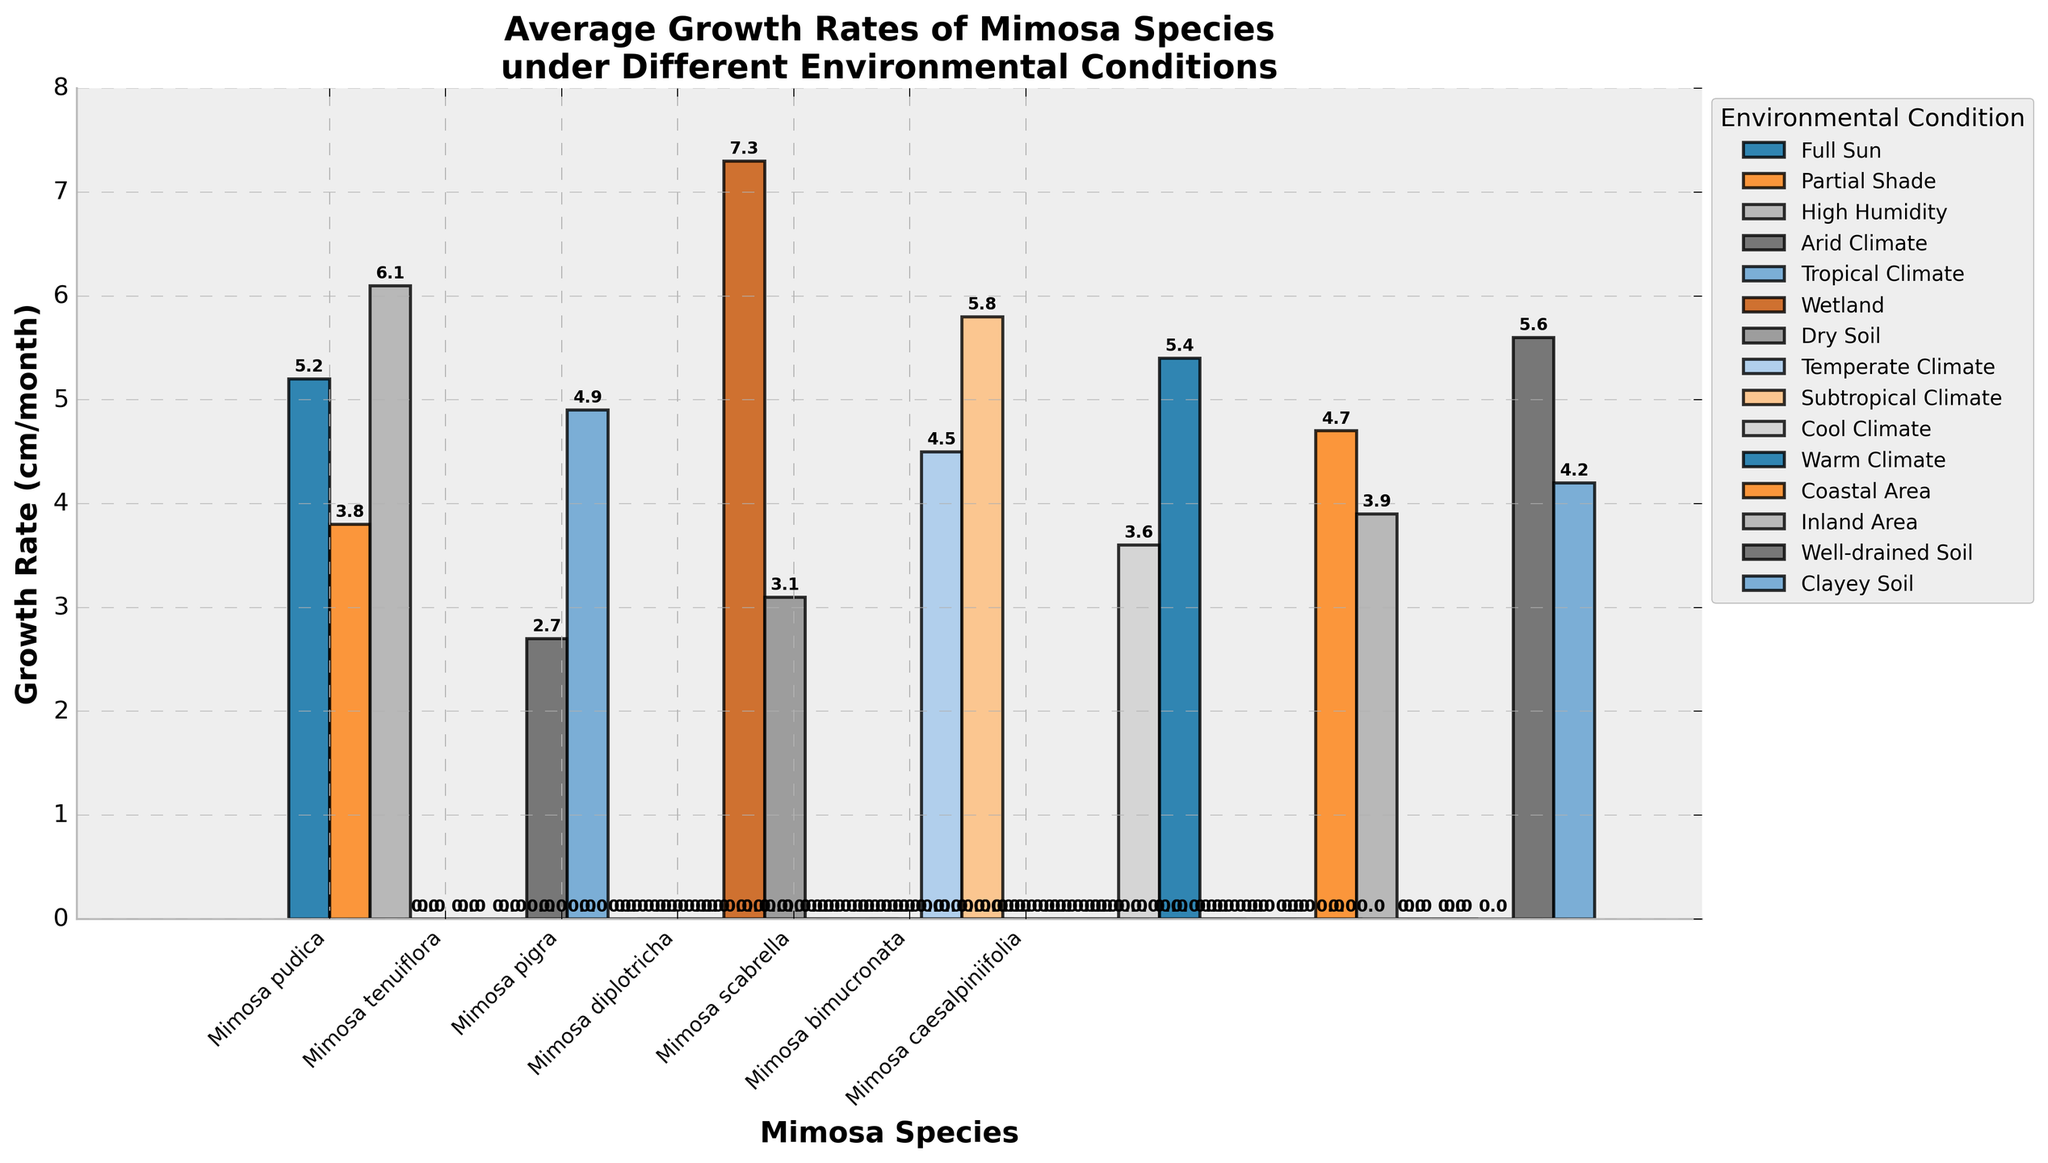What's the highest growth rate observed under any environmental condition? To find the highest growth rate, look at the tallest bar in the bar chart. The growth rate corresponding to that bar is the maximum value.
Answer: 7.3 cm/month Which Mimosa species has the greatest variation in growth rates across different conditions? Identify the species with bars representing the widest range of growth rates. The length difference between the tallest and shortest bar for each species represents the variation.
Answer: Mimosa pudica How does the growth rate of Mimosa pudica in Full Sun compare to its growth rate in High Humidity? Compare the height of the bars for Mimosa pudica under Full Sun and High Humidity conditions.
Answer: 5.2 cm/month (Full Sun) vs 6.1 cm/month (High Humidity) What's the average growth rate of Mimosa diplotricha across all observed conditions? Add the growth rates of Mimosa diplotricha across Temperate and Subtropical Climate conditions, then divide by the number of conditions. (4.5 + 5.8)/2 = 5.15 cm/month
Answer: 5.15 cm/month Which environmental condition yields the highest growth rate for Mimosa pigra and what is that rate? Identify the bar for Mimosa pigra with the highest value and note the corresponding environmental condition.
Answer: Wetland, 7.3 cm/month Is there a species with no observed growth rate under certain conditions? Scan the chart for any species that has no bar (or a bar with a height of 0) under one or more conditions.
Answer: No, all species have growth rates under at least one condition What's the difference between the highest and lowest growth rates for Mimosa caesalpiniifolia? Subtract the lowest growth rate from the highest growth rate for Mimosa caesalpiniifolia. 5.6 - 4.2 = 1.4 cm/month
Answer: 1.4 cm/month Compare the average growth rate of Mimosa scabrella in Cool Climate to that in Warm Climate. Look at the average value of the growth rates under Cool and Warm Climate for Mimosa scabrella. 3.6 cm/month (Cool Climate) vs 5.4 cm/month (Warm Climate)
Answer: 3.6 cm/month vs 5.4 cm/month 